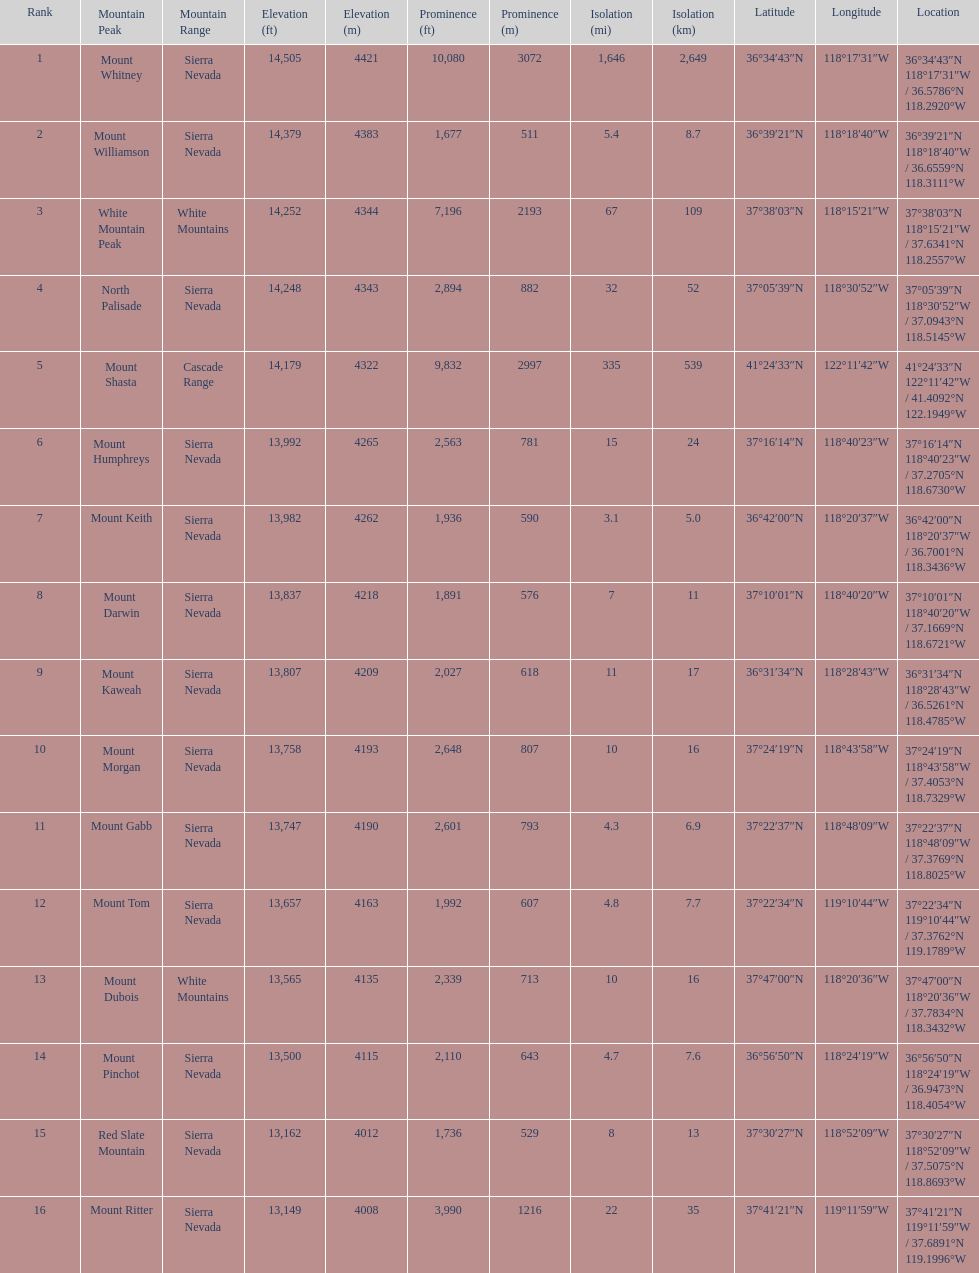What is the only mountain peak listed for the cascade range? Mount Shasta. 